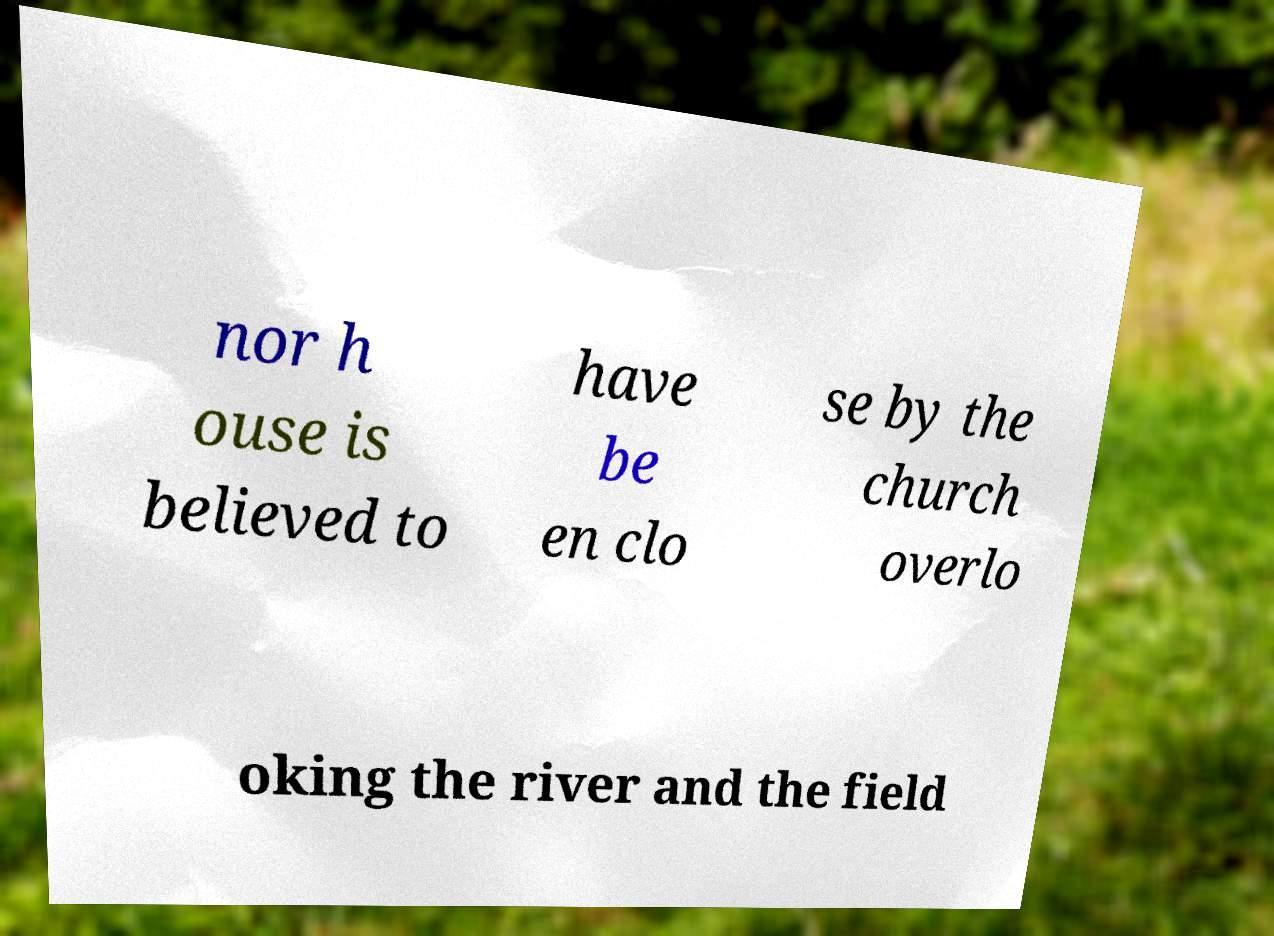Could you extract and type out the text from this image? nor h ouse is believed to have be en clo se by the church overlo oking the river and the field 